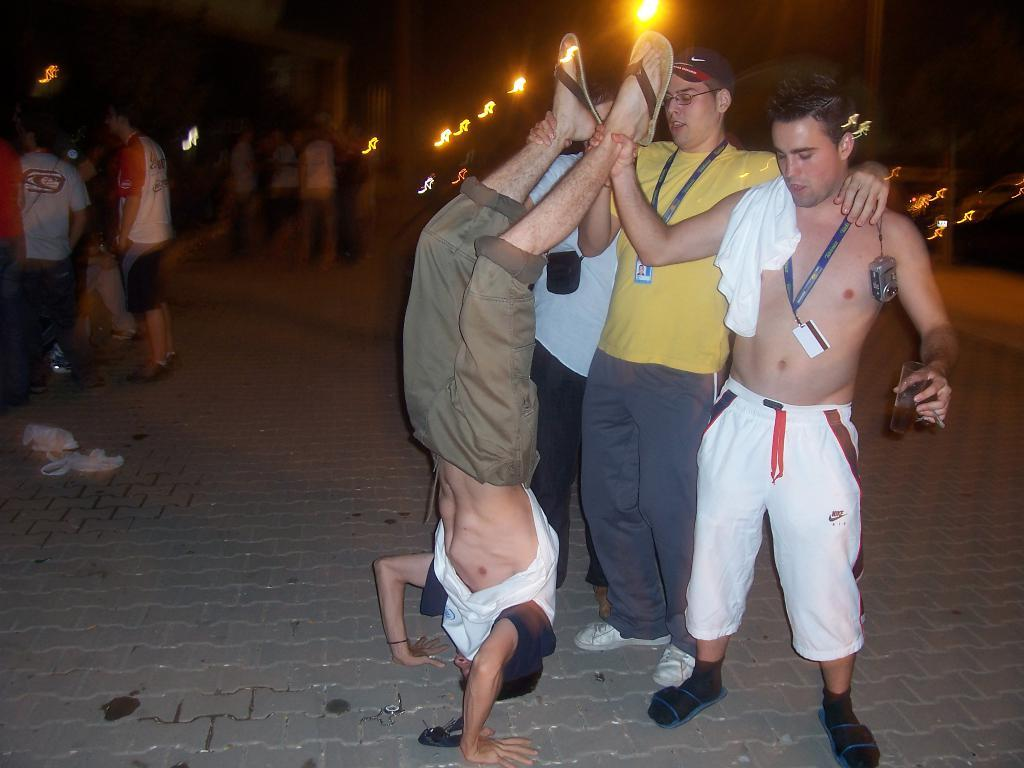What type of path is visible in the image? There is a footpath in the image. What can be seen on the footpath? There are people standing on the footpath. What type of lighting is present in the image? There are street lights in the image. What is the main surface visible in the image? There is a road in the image. What type of hall can be seen in the image? There is no hall present in the image; it features a footpath, people, street lights, and a road. 